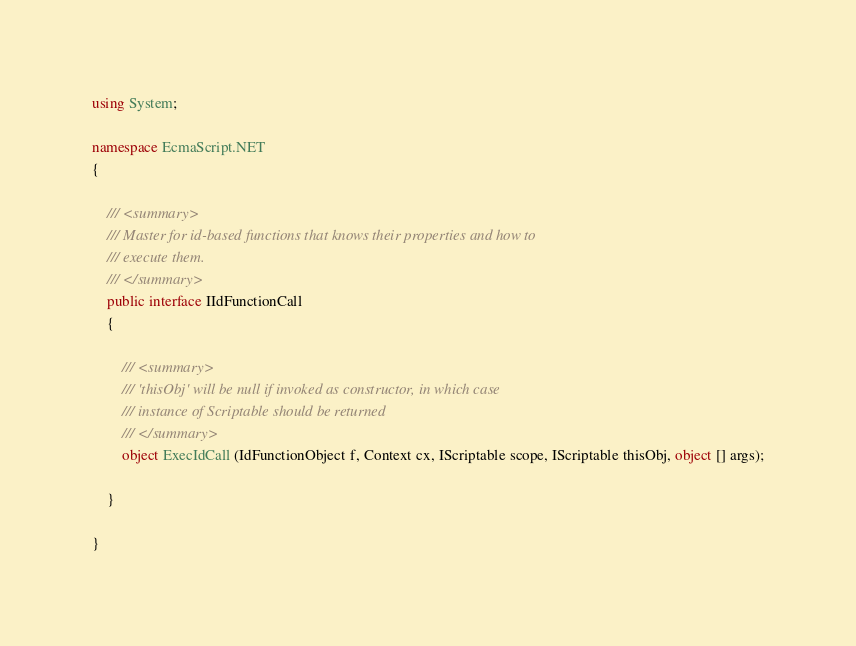<code> <loc_0><loc_0><loc_500><loc_500><_C#_>
using System;

namespace EcmaScript.NET
{

    /// <summary> 
    /// Master for id-based functions that knows their properties and how to
    /// execute them.
    /// </summary>
    public interface IIdFunctionCall
    {

        /// <summary> 
        /// 'thisObj' will be null if invoked as constructor, in which case
        /// instance of Scriptable should be returned
        /// </summary>
        object ExecIdCall (IdFunctionObject f, Context cx, IScriptable scope, IScriptable thisObj, object [] args);

    }

}</code> 